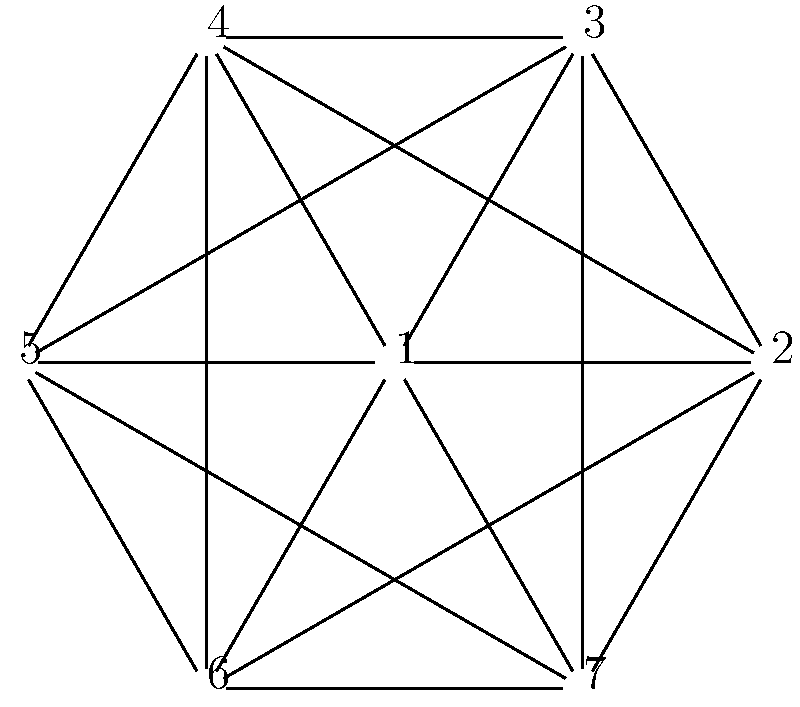Consider the graph above, which represents a map where each vertex is a region and edges connect adjacent regions. What is the minimum number of colors needed to color this map such that no two adjacent regions share the same color? Furthermore, propose an alternative coloring scheme that challenges the conventional approach. To solve this problem and propose an alternative approach, let's follow these steps:

1. Analyze the graph structure:
   The graph is a complete graph K7, where every vertex is connected to every other vertex.

2. Apply the conventional Four Color Theorem:
   The Four Color Theorem states that any planar graph can be colored with at most four colors. However, this graph is not planar.

3. Determine the chromatic number:
   For a complete graph Kn, the chromatic number is always n. In this case, n = 7.

4. Conventional coloring approach:
   Assign a unique color to each vertex, resulting in 7 colors total.

5. Alternative perspective:
   Challenge the notion that each region must be a solid color. Consider using color gradients or patterns instead of solid colors.

6. Propose an alternative coloring scheme:
   Use three base colors (e.g., red, blue, yellow) and create gradients between them for the remaining regions. For example:
   - Vertices 1-3: Solid red, blue, yellow
   - Vertices 4-5: Gradients between red-blue and blue-yellow
   - Vertices 6-7: Gradients between yellow-red and a tri-color blend

7. Advantages of the alternative approach:
   - Reduces the number of base colors needed
   - Creates a visually interesting map
   - Challenges the traditional concept of map coloring

8. Potential drawbacks:
   - May be more complex to implement
   - Could be less clear for color-blind individuals

This alternative approach maintains the distinction between adjacent regions while using fewer base colors and offering a fresh perspective on the map coloring problem.
Answer: Conventional: 7 colors. Alternative: 3 base colors with gradients. 